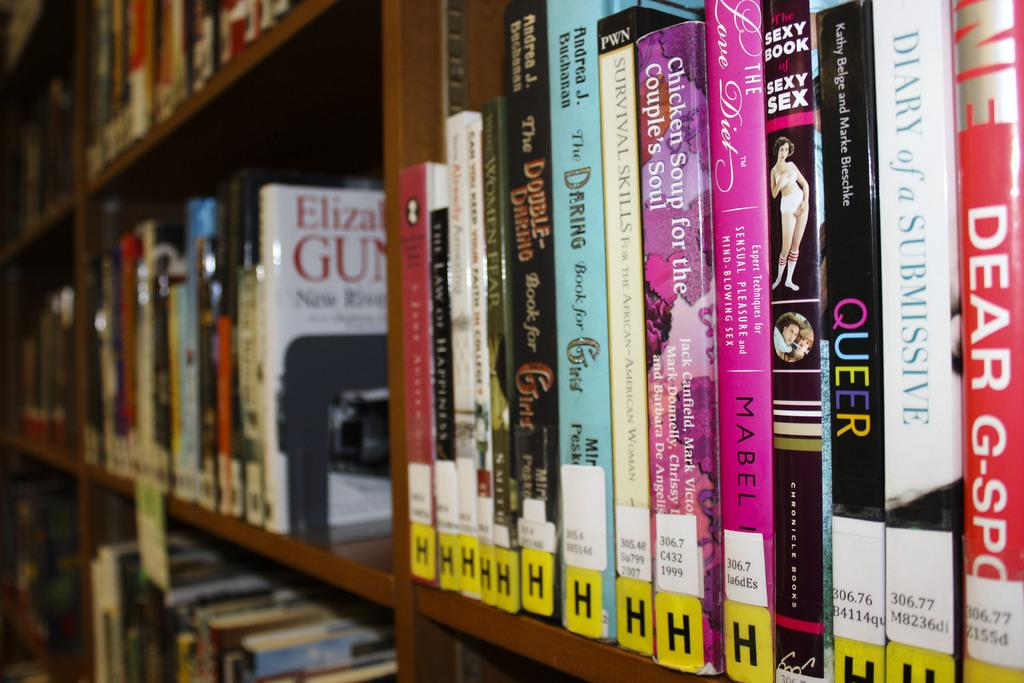Provide a one-sentence caption for the provided image. Several different books sitting in a library shelf with a yellow h label on the bottom of them. 